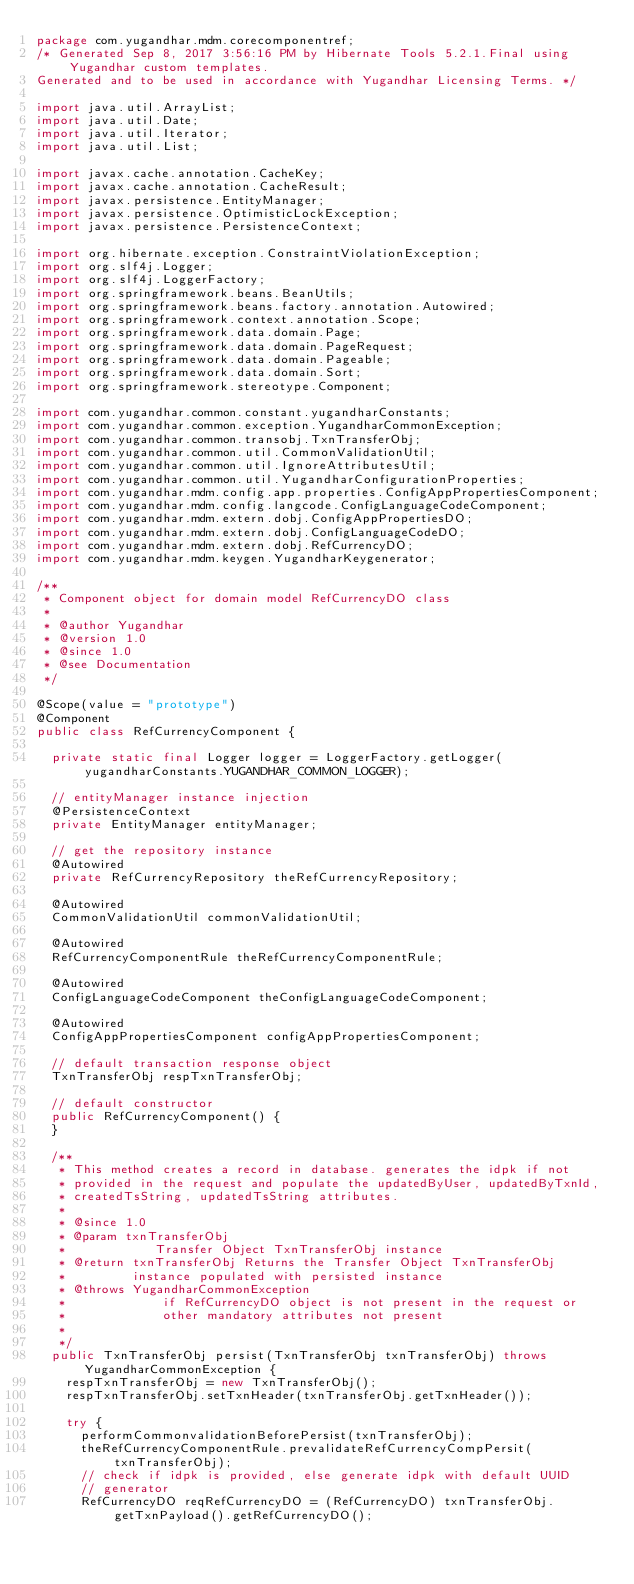<code> <loc_0><loc_0><loc_500><loc_500><_Java_>package com.yugandhar.mdm.corecomponentref;
/* Generated Sep 8, 2017 3:56:16 PM by Hibernate Tools 5.2.1.Final using Yugandhar custom templates. 
Generated and to be used in accordance with Yugandhar Licensing Terms. */

import java.util.ArrayList;
import java.util.Date;
import java.util.Iterator;
import java.util.List;

import javax.cache.annotation.CacheKey;
import javax.cache.annotation.CacheResult;
import javax.persistence.EntityManager;
import javax.persistence.OptimisticLockException;
import javax.persistence.PersistenceContext;

import org.hibernate.exception.ConstraintViolationException;
import org.slf4j.Logger;
import org.slf4j.LoggerFactory;
import org.springframework.beans.BeanUtils;
import org.springframework.beans.factory.annotation.Autowired;
import org.springframework.context.annotation.Scope;
import org.springframework.data.domain.Page;
import org.springframework.data.domain.PageRequest;
import org.springframework.data.domain.Pageable;
import org.springframework.data.domain.Sort;
import org.springframework.stereotype.Component;

import com.yugandhar.common.constant.yugandharConstants;
import com.yugandhar.common.exception.YugandharCommonException;
import com.yugandhar.common.transobj.TxnTransferObj;
import com.yugandhar.common.util.CommonValidationUtil;
import com.yugandhar.common.util.IgnoreAttributesUtil;
import com.yugandhar.common.util.YugandharConfigurationProperties;
import com.yugandhar.mdm.config.app.properties.ConfigAppPropertiesComponent;
import com.yugandhar.mdm.config.langcode.ConfigLanguageCodeComponent;
import com.yugandhar.mdm.extern.dobj.ConfigAppPropertiesDO;
import com.yugandhar.mdm.extern.dobj.ConfigLanguageCodeDO;
import com.yugandhar.mdm.extern.dobj.RefCurrencyDO;
import com.yugandhar.mdm.keygen.YugandharKeygenerator;

/**
 * Component object for domain model RefCurrencyDO class
 * 
 * @author Yugandhar
 * @version 1.0
 * @since 1.0
 * @see Documentation
 */

@Scope(value = "prototype")
@Component
public class RefCurrencyComponent {

	private static final Logger logger = LoggerFactory.getLogger(yugandharConstants.YUGANDHAR_COMMON_LOGGER);

	// entityManager instance injection
	@PersistenceContext
	private EntityManager entityManager;

	// get the repository instance
	@Autowired
	private RefCurrencyRepository theRefCurrencyRepository;

	@Autowired
	CommonValidationUtil commonValidationUtil;

	@Autowired
	RefCurrencyComponentRule theRefCurrencyComponentRule;

	@Autowired
	ConfigLanguageCodeComponent theConfigLanguageCodeComponent;

	@Autowired
	ConfigAppPropertiesComponent configAppPropertiesComponent;

	// default transaction response object
	TxnTransferObj respTxnTransferObj;

	// default constructor
	public RefCurrencyComponent() {
	}

	/**
	 * This method creates a record in database. generates the idpk if not
	 * provided in the request and populate the updatedByUser, updatedByTxnId,
	 * createdTsString, updatedTsString attributes.
	 * 
	 * @since 1.0
	 * @param txnTransferObj
	 *            Transfer Object TxnTransferObj instance
	 * @return txnTransferObj Returns the Transfer Object TxnTransferObj
	 *         instance populated with persisted instance
	 * @throws YugandharCommonException
	 *             if RefCurrencyDO object is not present in the request or
	 *             other mandatory attributes not present
	 *
	 */
	public TxnTransferObj persist(TxnTransferObj txnTransferObj) throws YugandharCommonException {
		respTxnTransferObj = new TxnTransferObj();
		respTxnTransferObj.setTxnHeader(txnTransferObj.getTxnHeader());

		try {
			performCommonvalidationBeforePersist(txnTransferObj);
			theRefCurrencyComponentRule.prevalidateRefCurrencyCompPersit(txnTransferObj);
			// check if idpk is provided, else generate idpk with default UUID
			// generator
			RefCurrencyDO reqRefCurrencyDO = (RefCurrencyDO) txnTransferObj.getTxnPayload().getRefCurrencyDO();</code> 